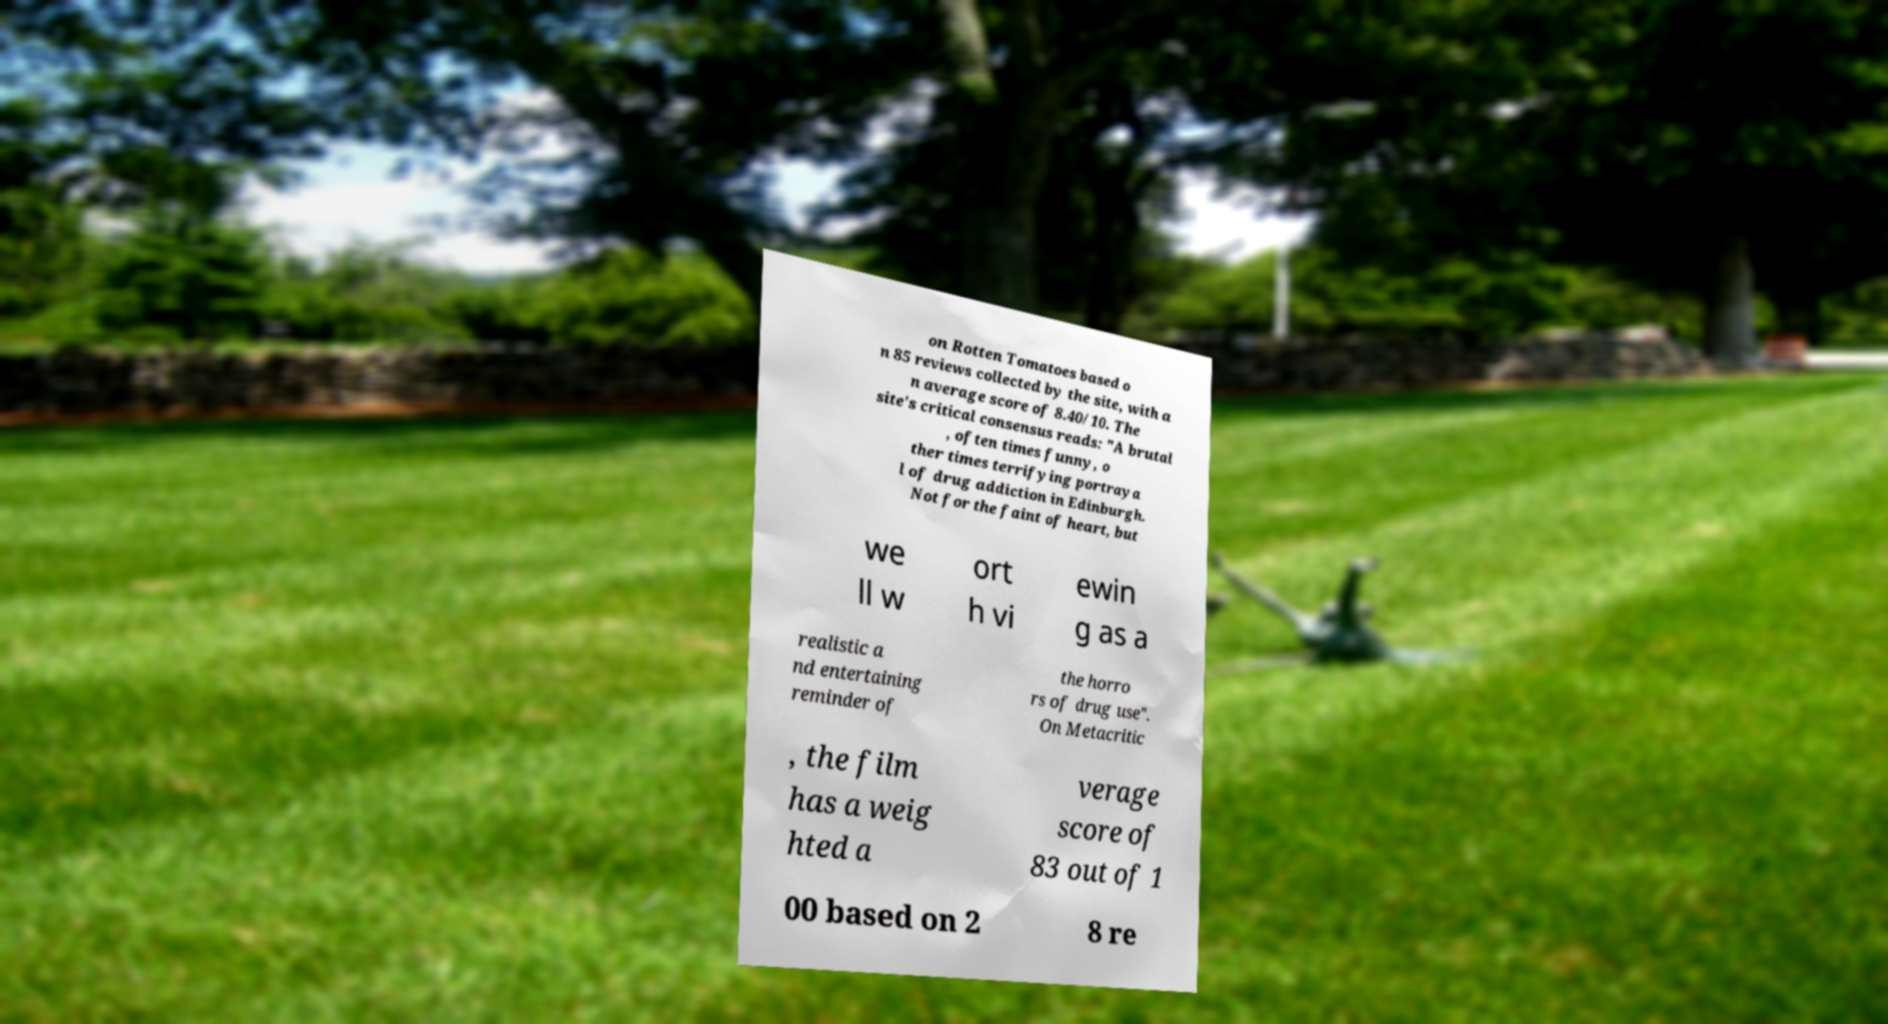Can you accurately transcribe the text from the provided image for me? on Rotten Tomatoes based o n 85 reviews collected by the site, with a n average score of 8.40/10. The site's critical consensus reads: "A brutal , often times funny, o ther times terrifying portraya l of drug addiction in Edinburgh. Not for the faint of heart, but we ll w ort h vi ewin g as a realistic a nd entertaining reminder of the horro rs of drug use". On Metacritic , the film has a weig hted a verage score of 83 out of 1 00 based on 2 8 re 